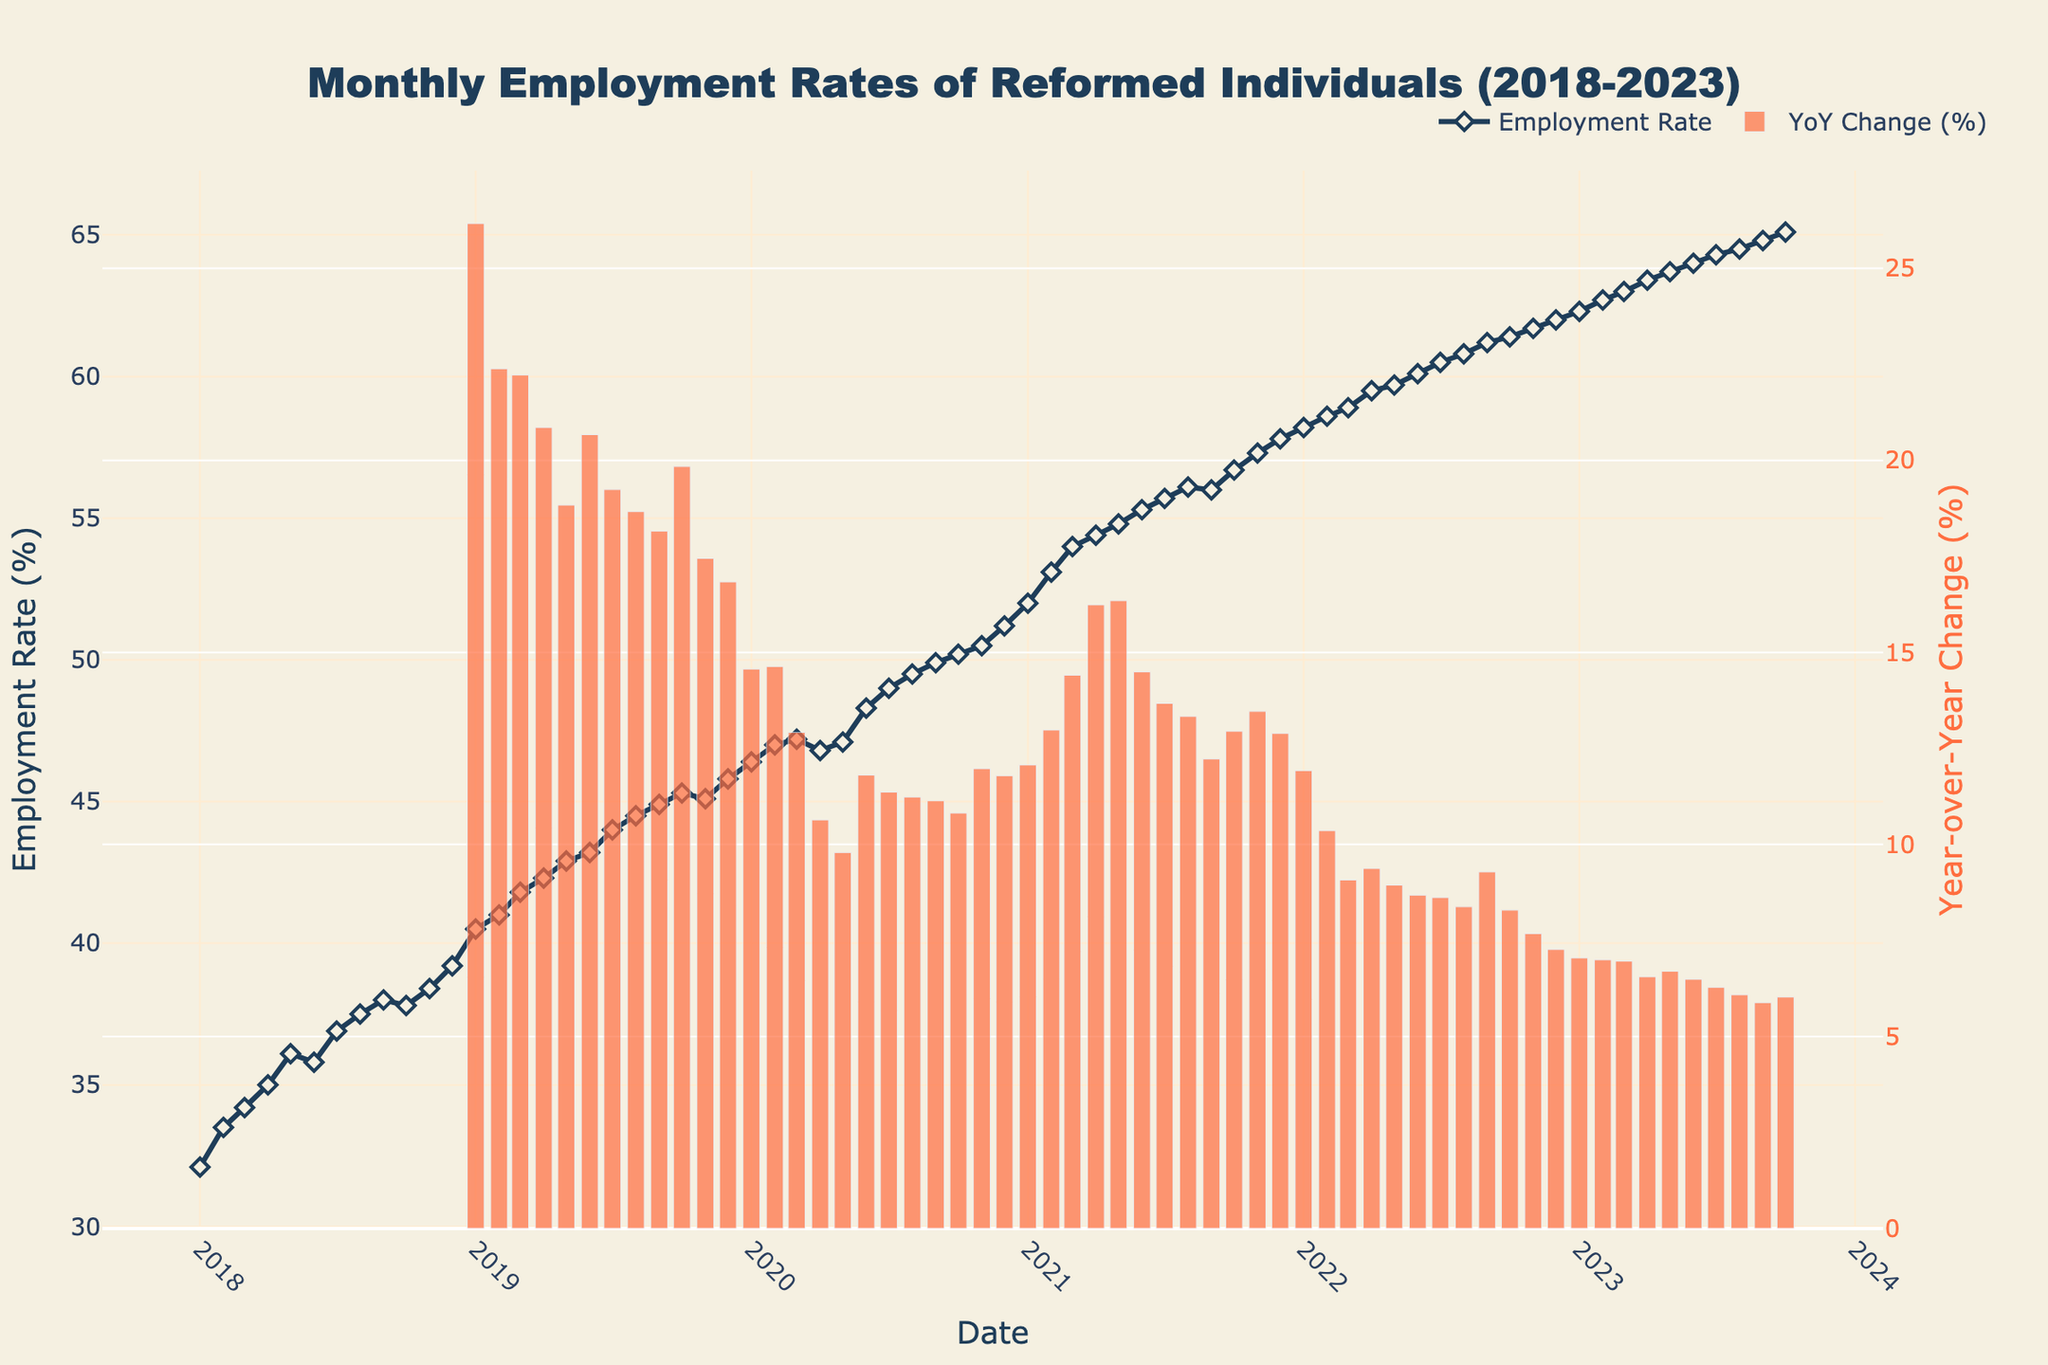What is the title of the figure? The title of the figure is usually located at the top in a larger and bolder font compared to other text elements.
Answer: Monthly Employment Rates of Reformed Individuals (2018-2023) What is the employment rate for January 2021? To find the employment rate for January 2021, locate the date on the x-axis and read the corresponding y-value.
Answer: 52.0% How many years of data are displayed in the figure? The figure shows data from January 2018 to October 2023. Counting the years from 2018 to 2023 gives us six years of data.
Answer: 6 years What is the trend in employment rates from mid-2018 to the end of 2020? Observe the line plot from mid-2018 to December 2020. The employment rate shows an overall increasing trend during this period.
Answer: Increasing trend What month experienced the highest employment rate, and what was it? The highest point on the line plot will show the month with the highest employment rate, which is October 2023.
Answer: October 2023, 65.1% What is the year-over-year (YoY) percentage change for January 2021? Locate the YoY change bar for January 2021 on the secondary y-axis, which represents the percentage change compared to January 2020.
Answer: Approximately 6% Compare the employment rate in January 2018 to January 2023. Which month has a higher rate and by how much? In January 2018, the rate is 32.1%, and in January 2023, it is 62.3%. January 2023 has a higher rate. The difference is 62.3% - 32.1% = 30.2%.
Answer: January 2023, by 30.2% Identify one significant dip in the employment rate and explain when it occurred. Notice a dip in the line plot around April 2020. The employment rate decreased around this period, partially recovering in subsequent months.
Answer: April 2020 Calculate the average employment rate for the year 2019. Sum the employment rates for each month of 2019 and divide by 12. Rates: 40.5, 41.0, 41.8, 42.3, 42.9, 43.2, 44.0, 44.5, 44.9, 45.3, 45.1, and 45.8. Sum: 526.3. Average: 526.3/12.
Answer: 43.9% How did the employment rate change between January 2020 and December 2020? Note the employment rates for January 2020 (46.4%) and December 2020 (51.2%). The change is 51.2% - 46.4%.
Answer: Increased by 4.8% 